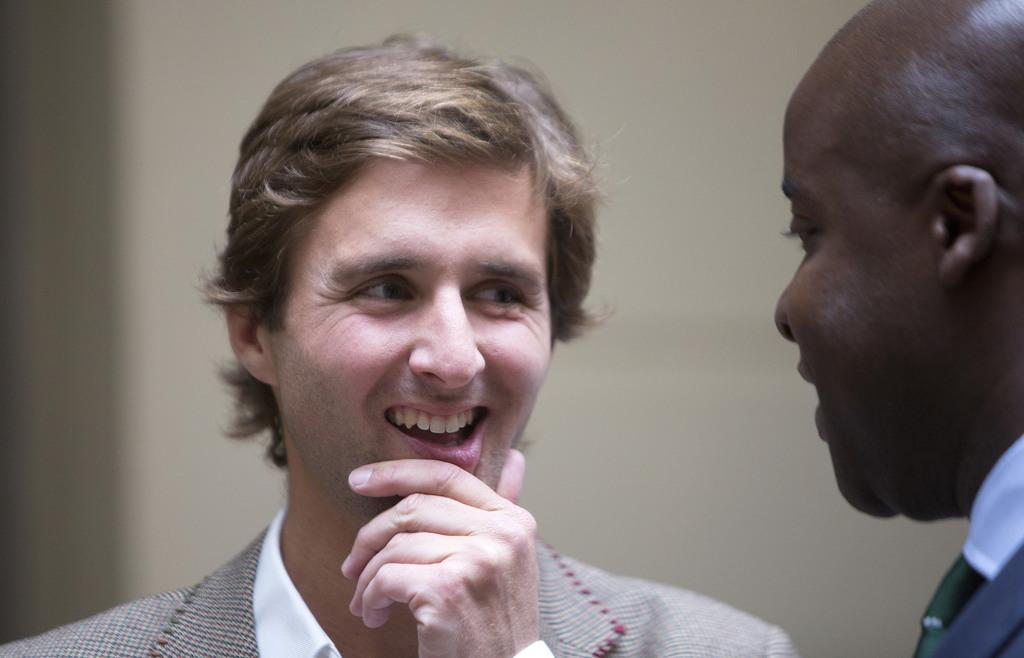How many people are in the image? There are two people in the image. What expressions do the people in the image have? The two people are smiling. What can be seen in the background of the image? There is a wall visible in the background of the image. What type of print can be seen on the army uniforms in the image? There is no mention of army uniforms or any type of print in the image. 